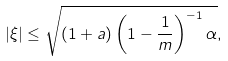<formula> <loc_0><loc_0><loc_500><loc_500>| \xi | \leq \sqrt { ( 1 + a ) \left ( 1 - \frac { 1 } { m } \right ) ^ { - 1 } \alpha } ,</formula> 